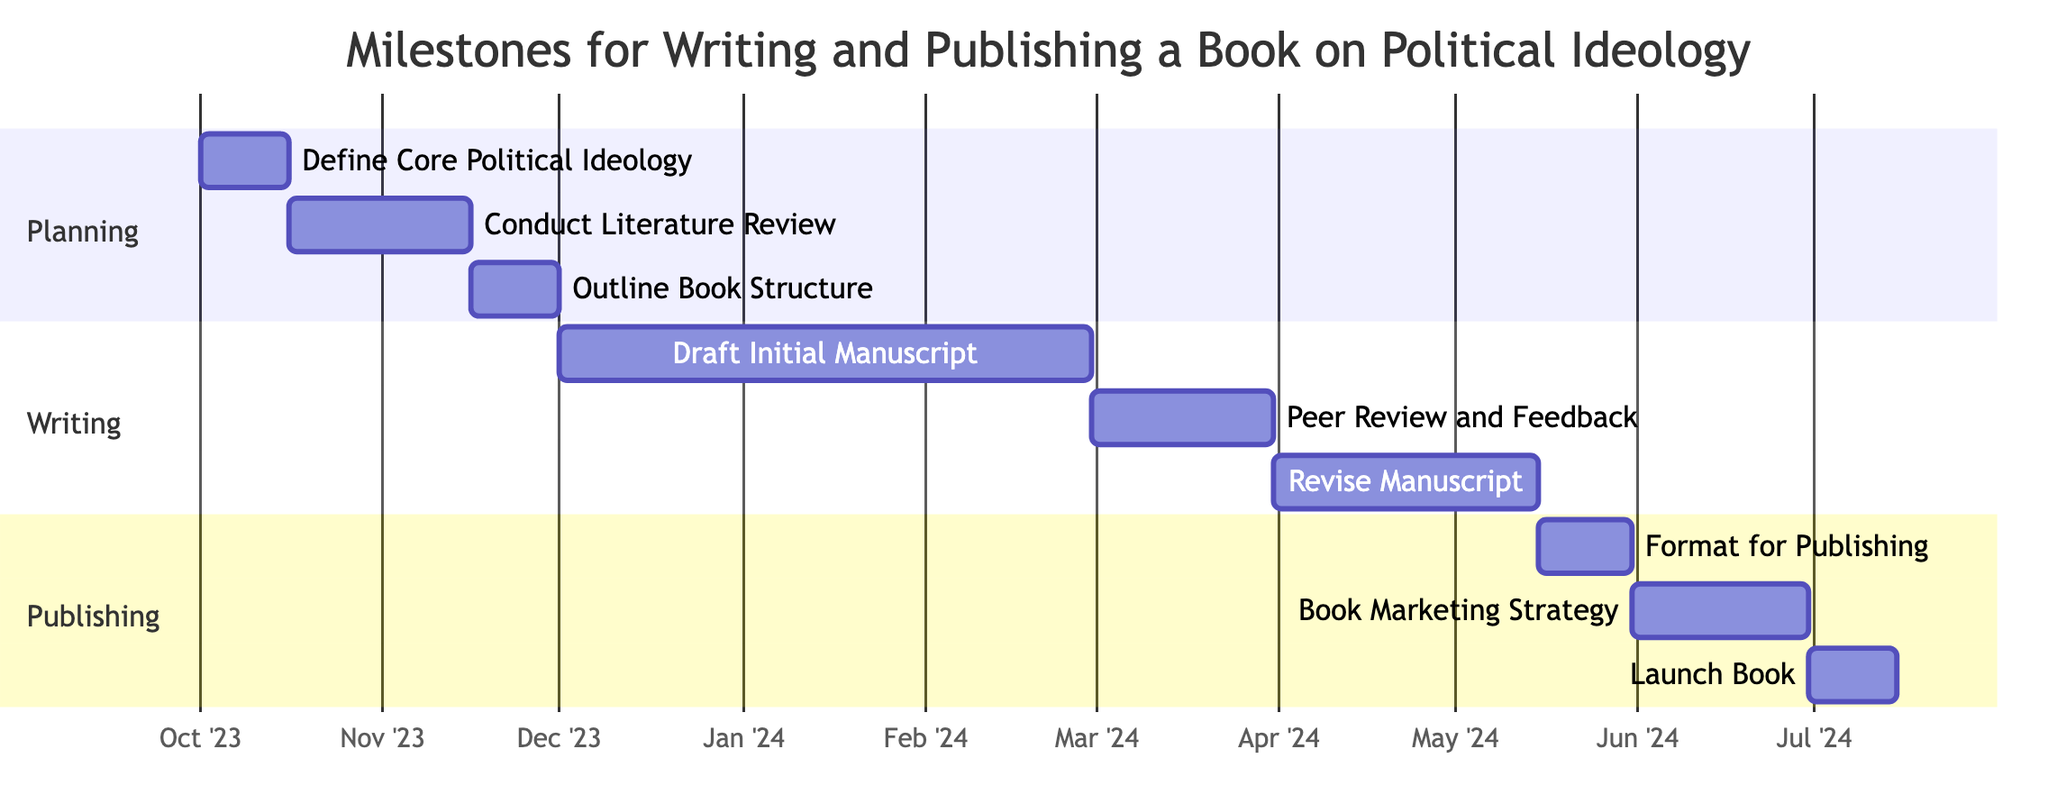What is the duration of the "Define Core Political Ideology" task? The task "Define Core Political Ideology" starts on October 1, 2023, and ends on October 15, 2023. The duration is 15 days.
Answer: 15 days Which task follows after "Conduct Literature Review"? The task "Outline Book Structure" follows immediately after "Conduct Literature Review," which ends on November 15, 2023.
Answer: Outline Book Structure How long does the "Draft Initial Manuscript" take? The "Draft Initial Manuscript" task starts on December 1, 2023, and ends on February 28, 2024. The total duration is 90 days.
Answer: 90 days What is the last task in the "Publishing" section? The last task in the "Publishing" section is "Launch Book," which starts after "Book Marketing Strategy."
Answer: Launch Book How many tasks are in the "Writing" section? The "Writing" section consists of three tasks: "Draft Initial Manuscript," "Peer Review and Feedback," and "Revise Manuscript."
Answer: 3 tasks What is the total duration from "Define Core Political Ideology" to "Launch Book"? To determine the total duration, we add the durations of all tasks sequentially from "Define Core Political Ideology" to "Launch Book." The total comes to 134 days.
Answer: 134 days When does the "Book Marketing Strategy" start? "Book Marketing Strategy" starts on June 1, 2024, following the completion of the "Format for Publishing" task.
Answer: June 1, 2024 What is the starting date for the "Peer Review and Feedback" task? The "Peer Review and Feedback" task begins the day after the "Draft Initial Manuscript" task, which ends on February 28, 2024. Therefore, it starts on March 1, 2024.
Answer: March 1, 2024 Which task has the longest duration in the diagram? The task with the longest duration is "Draft Initial Manuscript," which takes 90 days to complete.
Answer: Draft Initial Manuscript 